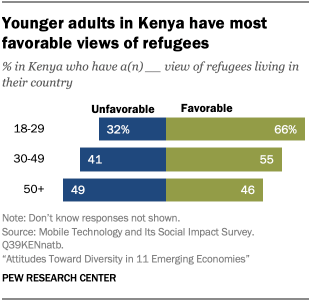Draw attention to some important aspects in this diagram. The ratio of the highest value of the 30-49 age group to the 18-29 age group is 0.2125. According to the data, the percentage of the 30-49 age group in Kenya with a favorable view of refugees living in their country is 0.55. 